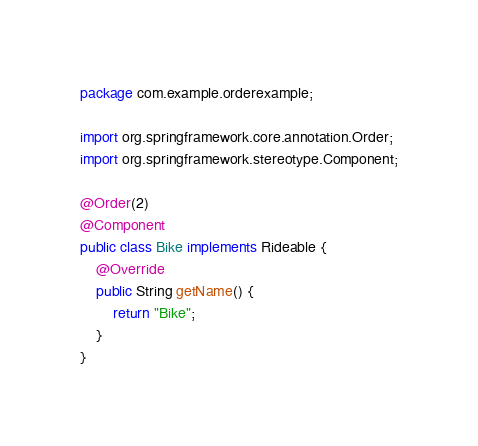<code> <loc_0><loc_0><loc_500><loc_500><_Java_>package com.example.orderexample;

import org.springframework.core.annotation.Order;
import org.springframework.stereotype.Component;

@Order(2)
@Component
public class Bike implements Rideable {
    @Override
    public String getName() {
        return "Bike";
    }
}
</code> 